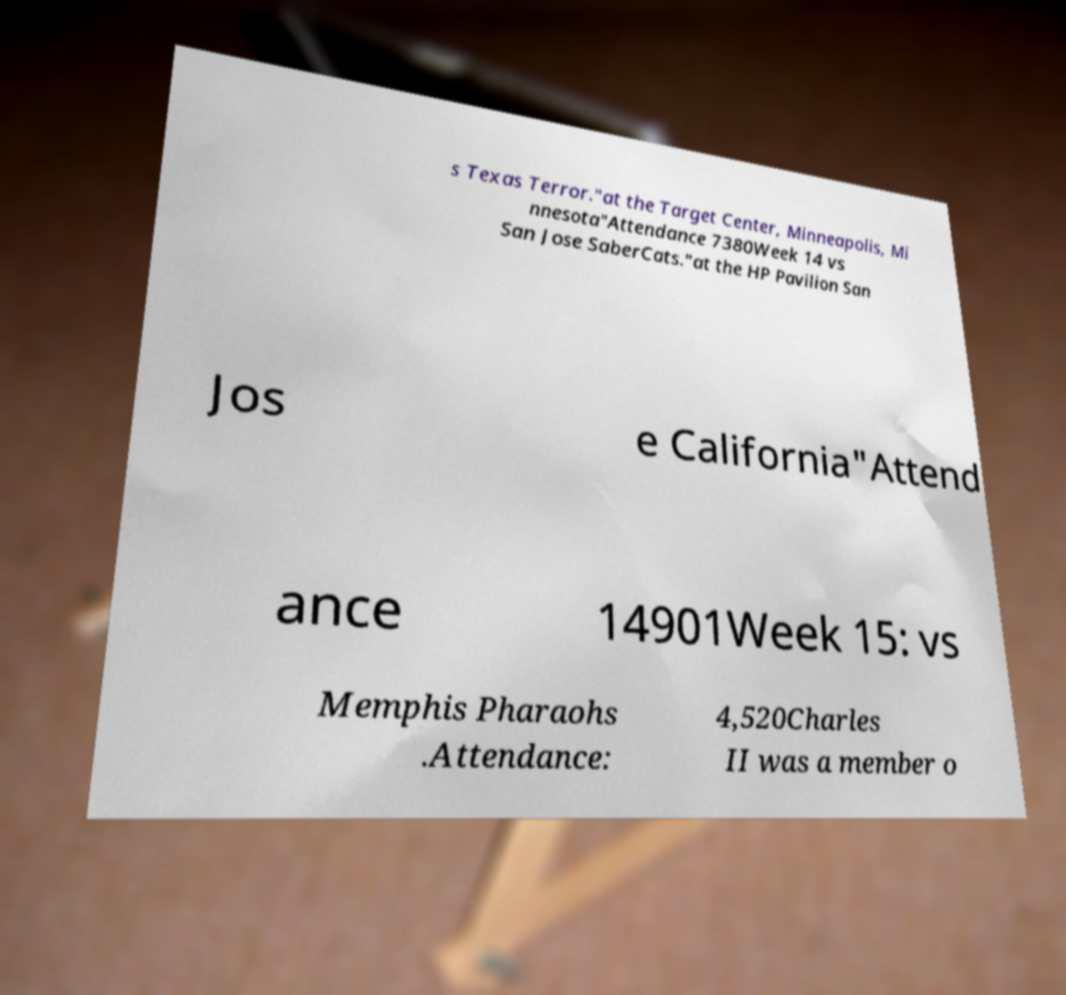Could you assist in decoding the text presented in this image and type it out clearly? s Texas Terror."at the Target Center, Minneapolis, Mi nnesota"Attendance 7380Week 14 vs San Jose SaberCats."at the HP Pavilion San Jos e California"Attend ance 14901Week 15: vs Memphis Pharaohs .Attendance: 4,520Charles II was a member o 